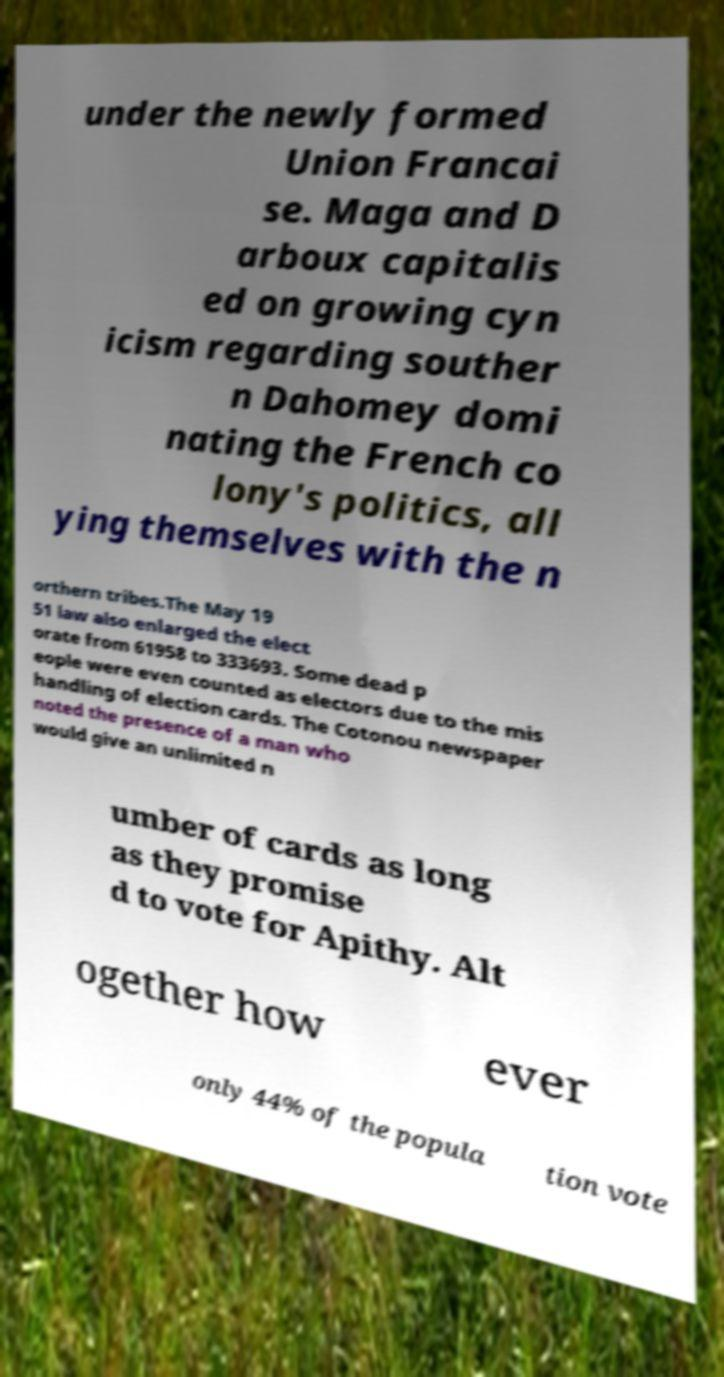What messages or text are displayed in this image? I need them in a readable, typed format. under the newly formed Union Francai se. Maga and D arboux capitalis ed on growing cyn icism regarding souther n Dahomey domi nating the French co lony's politics, all ying themselves with the n orthern tribes.The May 19 51 law also enlarged the elect orate from 61958 to 333693. Some dead p eople were even counted as electors due to the mis handling of election cards. The Cotonou newspaper noted the presence of a man who would give an unlimited n umber of cards as long as they promise d to vote for Apithy. Alt ogether how ever only 44% of the popula tion vote 